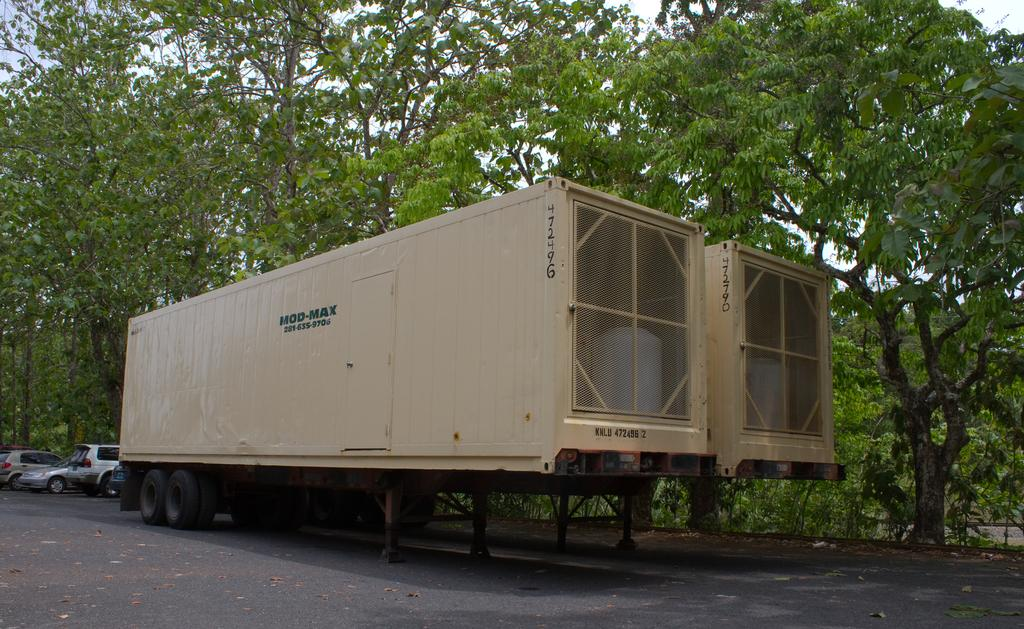What can be seen beside the road in the image? There are vehicles parked beside the road in the image. What type of natural elements are visible in the image? There are trees visible in the image. Can you hear the donkey braying in the image? There is no donkey present in the image, so it is not possible to hear it braying. What color is the wrist of the person in the image? There is no person present in the image, so it is not possible to determine the color of their wrist. 